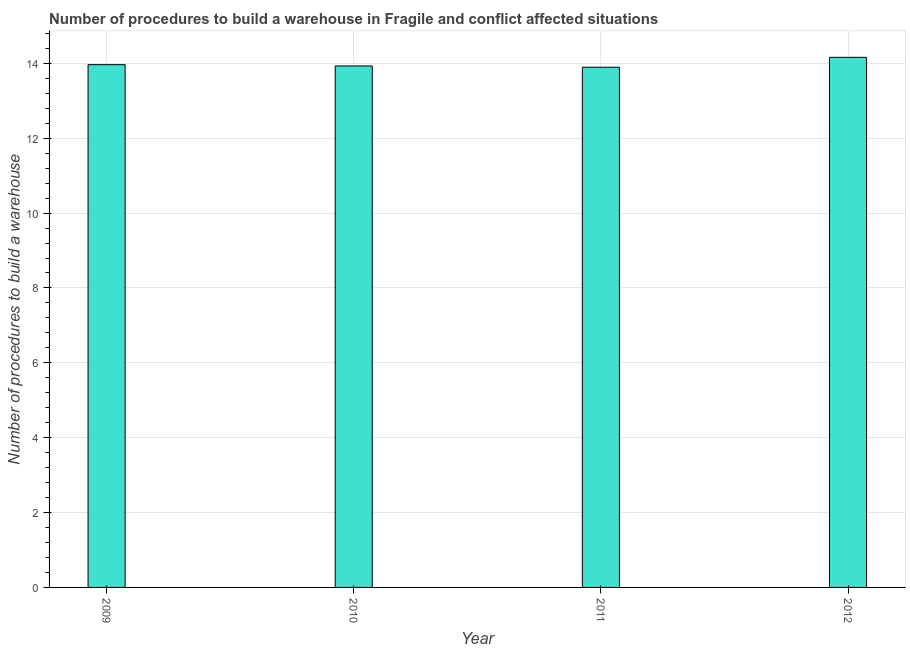Does the graph contain any zero values?
Ensure brevity in your answer.  No. Does the graph contain grids?
Ensure brevity in your answer.  Yes. What is the title of the graph?
Your answer should be very brief. Number of procedures to build a warehouse in Fragile and conflict affected situations. What is the label or title of the X-axis?
Make the answer very short. Year. What is the label or title of the Y-axis?
Give a very brief answer. Number of procedures to build a warehouse. What is the number of procedures to build a warehouse in 2012?
Your response must be concise. 14.16. Across all years, what is the maximum number of procedures to build a warehouse?
Give a very brief answer. 14.16. Across all years, what is the minimum number of procedures to build a warehouse?
Your answer should be compact. 13.9. What is the sum of the number of procedures to build a warehouse?
Keep it short and to the point. 55.95. What is the difference between the number of procedures to build a warehouse in 2010 and 2012?
Your answer should be very brief. -0.23. What is the average number of procedures to build a warehouse per year?
Offer a terse response. 13.99. What is the median number of procedures to build a warehouse?
Provide a short and direct response. 13.95. Do a majority of the years between 2009 and 2010 (inclusive) have number of procedures to build a warehouse greater than 4.8 ?
Offer a terse response. Yes. What is the ratio of the number of procedures to build a warehouse in 2010 to that in 2012?
Keep it short and to the point. 0.98. Is the number of procedures to build a warehouse in 2010 less than that in 2012?
Make the answer very short. Yes. What is the difference between the highest and the second highest number of procedures to build a warehouse?
Offer a very short reply. 0.2. Is the sum of the number of procedures to build a warehouse in 2009 and 2011 greater than the maximum number of procedures to build a warehouse across all years?
Make the answer very short. Yes. What is the difference between the highest and the lowest number of procedures to build a warehouse?
Make the answer very short. 0.26. What is the Number of procedures to build a warehouse of 2009?
Provide a succinct answer. 13.97. What is the Number of procedures to build a warehouse in 2010?
Ensure brevity in your answer.  13.93. What is the Number of procedures to build a warehouse of 2011?
Offer a terse response. 13.9. What is the Number of procedures to build a warehouse of 2012?
Your response must be concise. 14.16. What is the difference between the Number of procedures to build a warehouse in 2009 and 2010?
Ensure brevity in your answer.  0.03. What is the difference between the Number of procedures to build a warehouse in 2009 and 2011?
Your response must be concise. 0.07. What is the difference between the Number of procedures to build a warehouse in 2009 and 2012?
Your answer should be very brief. -0.2. What is the difference between the Number of procedures to build a warehouse in 2010 and 2011?
Make the answer very short. 0.03. What is the difference between the Number of procedures to build a warehouse in 2010 and 2012?
Provide a succinct answer. -0.23. What is the difference between the Number of procedures to build a warehouse in 2011 and 2012?
Give a very brief answer. -0.26. What is the ratio of the Number of procedures to build a warehouse in 2010 to that in 2011?
Offer a terse response. 1. What is the ratio of the Number of procedures to build a warehouse in 2010 to that in 2012?
Provide a short and direct response. 0.98. What is the ratio of the Number of procedures to build a warehouse in 2011 to that in 2012?
Give a very brief answer. 0.98. 